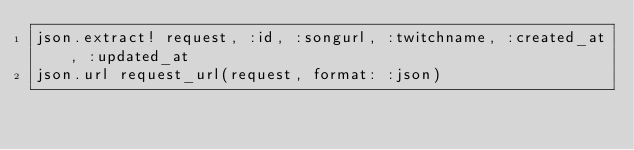<code> <loc_0><loc_0><loc_500><loc_500><_Ruby_>json.extract! request, :id, :songurl, :twitchname, :created_at, :updated_at
json.url request_url(request, format: :json)
</code> 